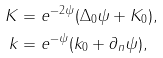<formula> <loc_0><loc_0><loc_500><loc_500>K & = e ^ { - 2 \psi } ( \Delta _ { 0 } \psi + K _ { 0 } ) , \\ k & = e ^ { - \psi } ( k _ { 0 } + \partial _ { n } \psi ) ,</formula> 